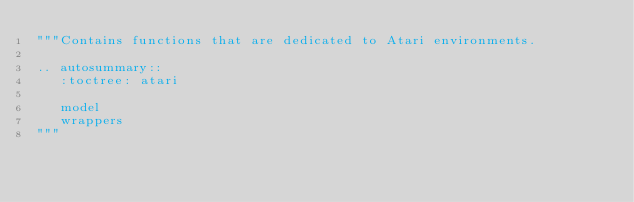<code> <loc_0><loc_0><loc_500><loc_500><_Python_>"""Contains functions that are dedicated to Atari environments.

.. autosummary::
   :toctree: atari

   model
   wrappers
"""
</code> 